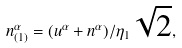<formula> <loc_0><loc_0><loc_500><loc_500>n _ { ( 1 ) } ^ { \alpha } = ( u ^ { \alpha } + n ^ { \alpha } ) / \eta _ { 1 } \sqrt { 2 } ,</formula> 